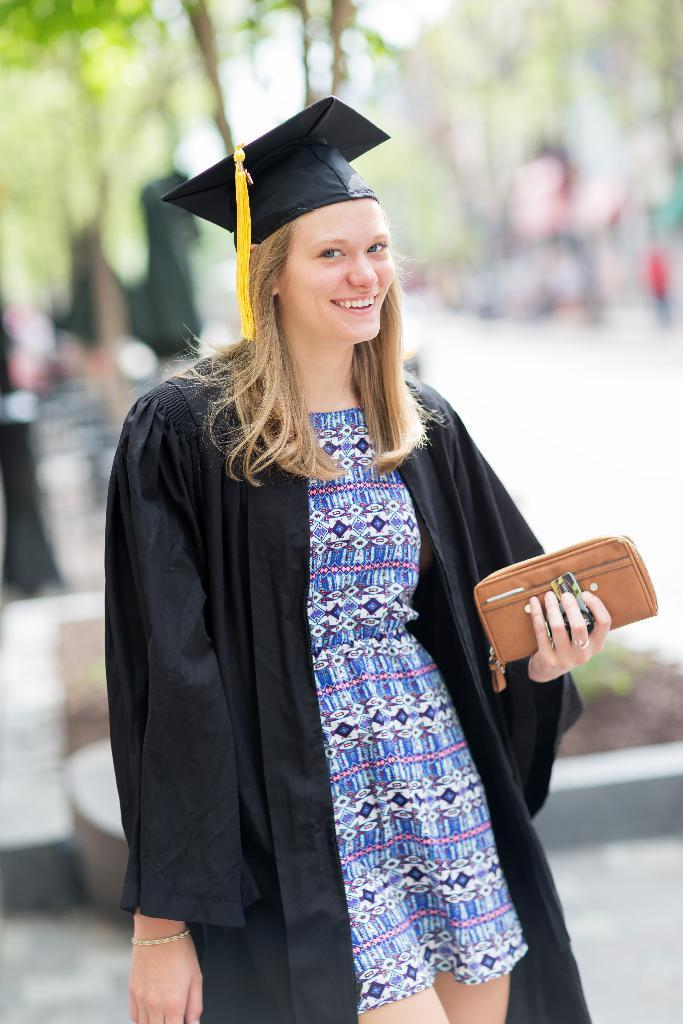Who is present in the image? There is a woman in the image. What is the woman doing in the image? The woman is smiling in the image. What is the woman holding in the image? The woman is holding a purse with her hand. What can be seen in the background of the image? There are trees in the background of the image. What type of mint is growing near the woman in the image? There is no mint visible in the image. 